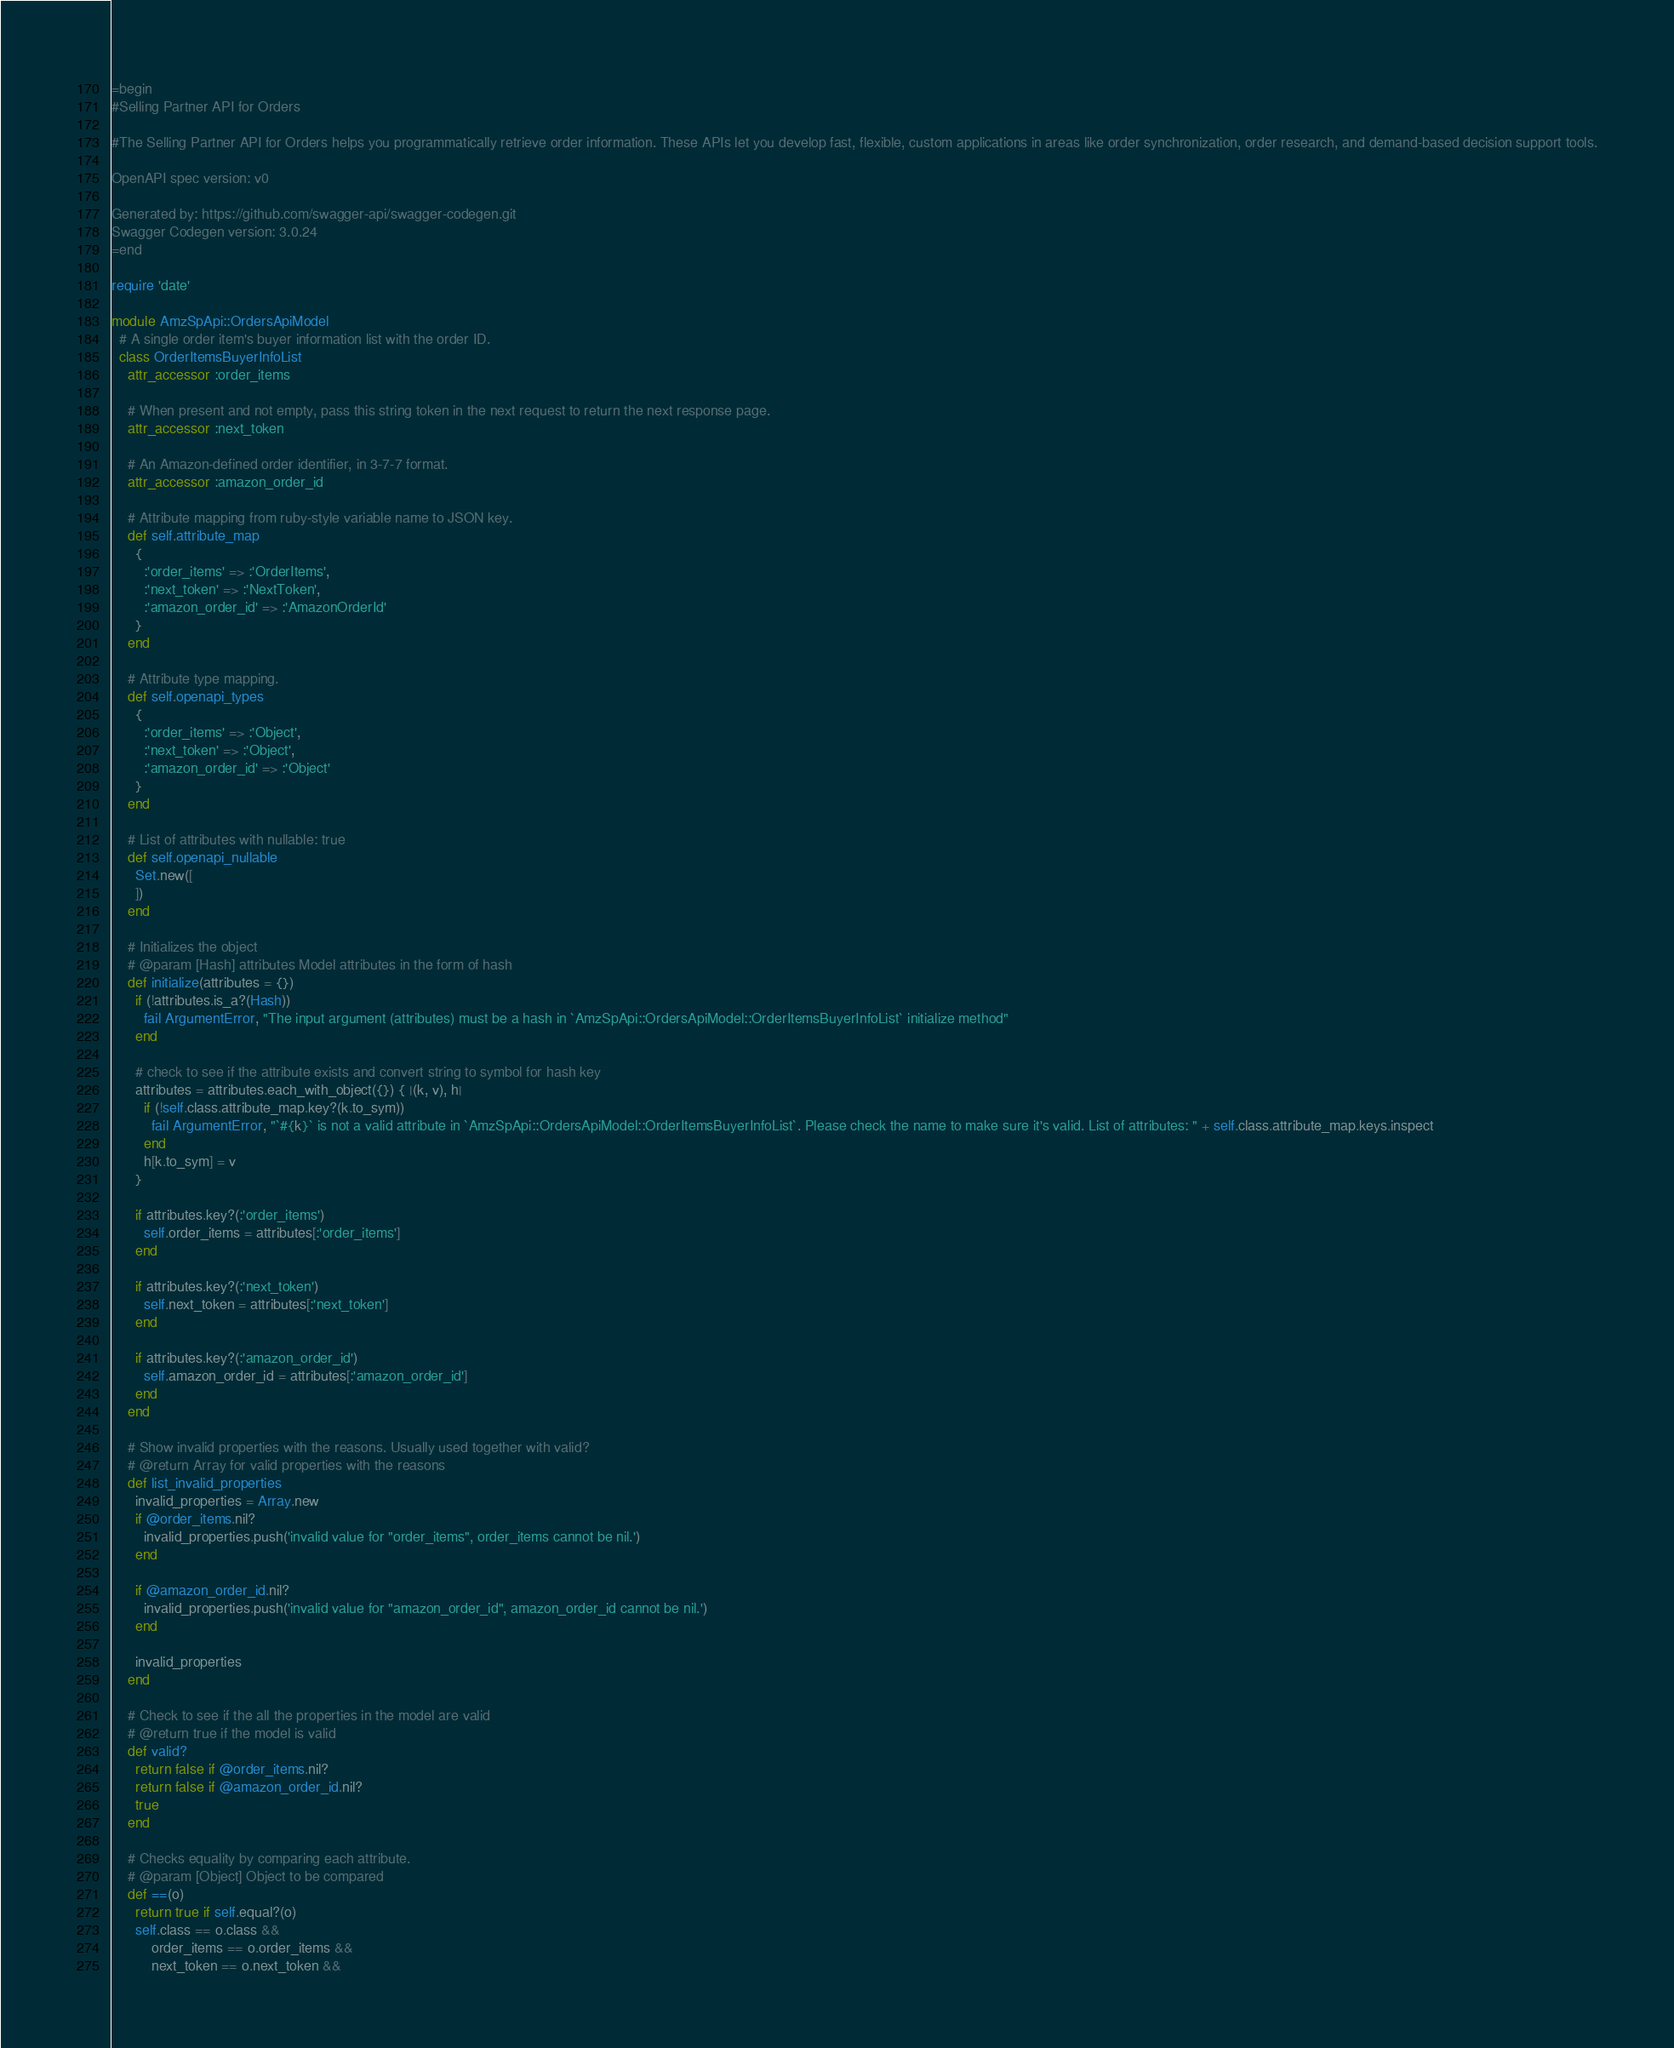Convert code to text. <code><loc_0><loc_0><loc_500><loc_500><_Ruby_>=begin
#Selling Partner API for Orders

#The Selling Partner API for Orders helps you programmatically retrieve order information. These APIs let you develop fast, flexible, custom applications in areas like order synchronization, order research, and demand-based decision support tools.

OpenAPI spec version: v0

Generated by: https://github.com/swagger-api/swagger-codegen.git
Swagger Codegen version: 3.0.24
=end

require 'date'

module AmzSpApi::OrdersApiModel
  # A single order item's buyer information list with the order ID.
  class OrderItemsBuyerInfoList
    attr_accessor :order_items

    # When present and not empty, pass this string token in the next request to return the next response page.
    attr_accessor :next_token

    # An Amazon-defined order identifier, in 3-7-7 format.
    attr_accessor :amazon_order_id

    # Attribute mapping from ruby-style variable name to JSON key.
    def self.attribute_map
      {
        :'order_items' => :'OrderItems',
        :'next_token' => :'NextToken',
        :'amazon_order_id' => :'AmazonOrderId'
      }
    end

    # Attribute type mapping.
    def self.openapi_types
      {
        :'order_items' => :'Object',
        :'next_token' => :'Object',
        :'amazon_order_id' => :'Object'
      }
    end

    # List of attributes with nullable: true
    def self.openapi_nullable
      Set.new([
      ])
    end
  
    # Initializes the object
    # @param [Hash] attributes Model attributes in the form of hash
    def initialize(attributes = {})
      if (!attributes.is_a?(Hash))
        fail ArgumentError, "The input argument (attributes) must be a hash in `AmzSpApi::OrdersApiModel::OrderItemsBuyerInfoList` initialize method"
      end

      # check to see if the attribute exists and convert string to symbol for hash key
      attributes = attributes.each_with_object({}) { |(k, v), h|
        if (!self.class.attribute_map.key?(k.to_sym))
          fail ArgumentError, "`#{k}` is not a valid attribute in `AmzSpApi::OrdersApiModel::OrderItemsBuyerInfoList`. Please check the name to make sure it's valid. List of attributes: " + self.class.attribute_map.keys.inspect
        end
        h[k.to_sym] = v
      }

      if attributes.key?(:'order_items')
        self.order_items = attributes[:'order_items']
      end

      if attributes.key?(:'next_token')
        self.next_token = attributes[:'next_token']
      end

      if attributes.key?(:'amazon_order_id')
        self.amazon_order_id = attributes[:'amazon_order_id']
      end
    end

    # Show invalid properties with the reasons. Usually used together with valid?
    # @return Array for valid properties with the reasons
    def list_invalid_properties
      invalid_properties = Array.new
      if @order_items.nil?
        invalid_properties.push('invalid value for "order_items", order_items cannot be nil.')
      end

      if @amazon_order_id.nil?
        invalid_properties.push('invalid value for "amazon_order_id", amazon_order_id cannot be nil.')
      end

      invalid_properties
    end

    # Check to see if the all the properties in the model are valid
    # @return true if the model is valid
    def valid?
      return false if @order_items.nil?
      return false if @amazon_order_id.nil?
      true
    end

    # Checks equality by comparing each attribute.
    # @param [Object] Object to be compared
    def ==(o)
      return true if self.equal?(o)
      self.class == o.class &&
          order_items == o.order_items &&
          next_token == o.next_token &&</code> 